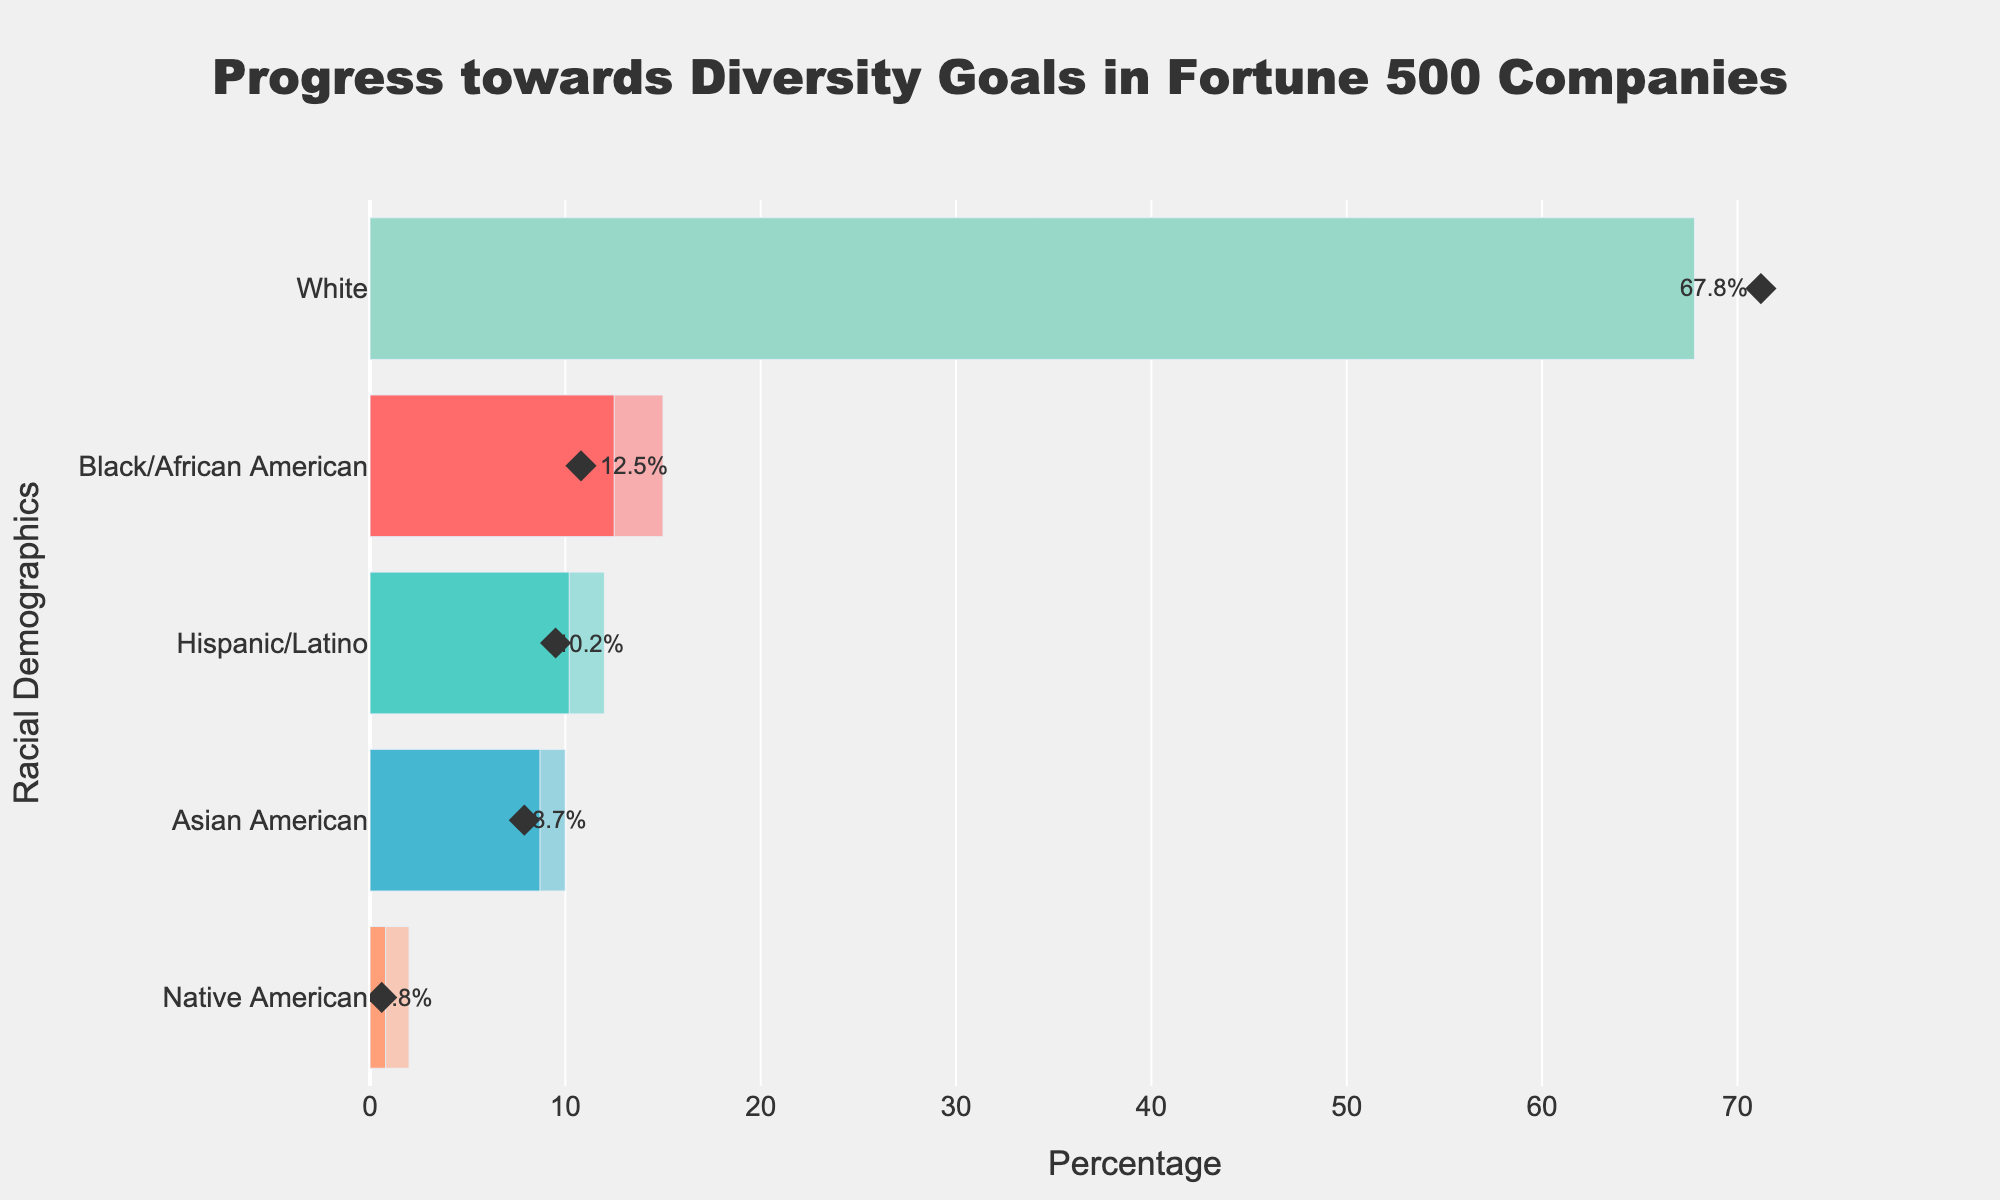Which racial demographic has the highest "Actual" percentage? By looking at the "Actual" bars in the chart, the white demographic has the highest actual percentage.
Answer: White What is the difference between the "Target" and "Actual" percentages for the Hispanic/Latino demographic? The target percentage for the Hispanic/Latino demographic is 12%, and the actual percentage is 10.2%. The difference is 12% - 10.2% = 1.8%.
Answer: 1.8% How does the "Actual" percentage for Native Americans compare to their "Target" percentage? The actual percentage for Native Americans is 0.8%, which is significantly lower than their target percentage of 2%.
Answer: Lower Which demographic is closest to meeting their "Target" percentage based on their "Actual" percentage? By comparing the actual percentages to their respective targets, Black/African American is closest to meeting their target, with an actual percentage of 12.5% and a target of 15%.
Answer: Black/African American Is the "Comparison" marker for the Asian American demographic higher or lower than their "Actual" percentage? The comparison marker for the Asian American demographic is at 7.9%, which is lower than their actual percentage of 8.7%.
Answer: Lower For the White demographic, how much does their "Actual" percentage exceed their "Target" percentage? The actual percentage for the white demographic is 67.8%, while their target percentage is 61%. The difference is 67.8% - 61% = 6.8%.
Answer: 6.8% Which demographic has the largest gap between its "Target" and "Actual" percentages? By looking at the target and actual percentages across all demographics, Native Americans have the largest gap, with a target of 2% and an actual of 0.8%, producing a gap of 1.2%.
Answer: Native American What is the rank order of demographics based on their "Actual" percentages from highest to lowest? By sorting the actual percentages from highest to lowest: White (67.8%), Black/African American (12.5%), Hispanic/Latino (10.2%), Asian American (8.7%), Native American (0.8%).
Answer: White, Black/African American, Hispanic/Latino, Asian American, Native American By how much does the "Actual" percentage of the Black/African American demographic exceed the "Comparison" marker? The actual percentage for the Black/African American demographic is 12.5%, while the comparison marker is at 10.8%. The difference is 12.5% - 10.8% = 1.7%.
Answer: 1.7% 